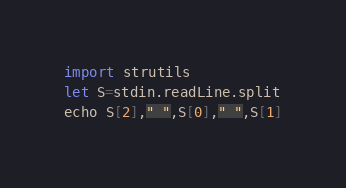Convert code to text. <code><loc_0><loc_0><loc_500><loc_500><_Nim_>import strutils
let S=stdin.readLine.split
echo S[2]," ",S[0]," ",S[1]</code> 